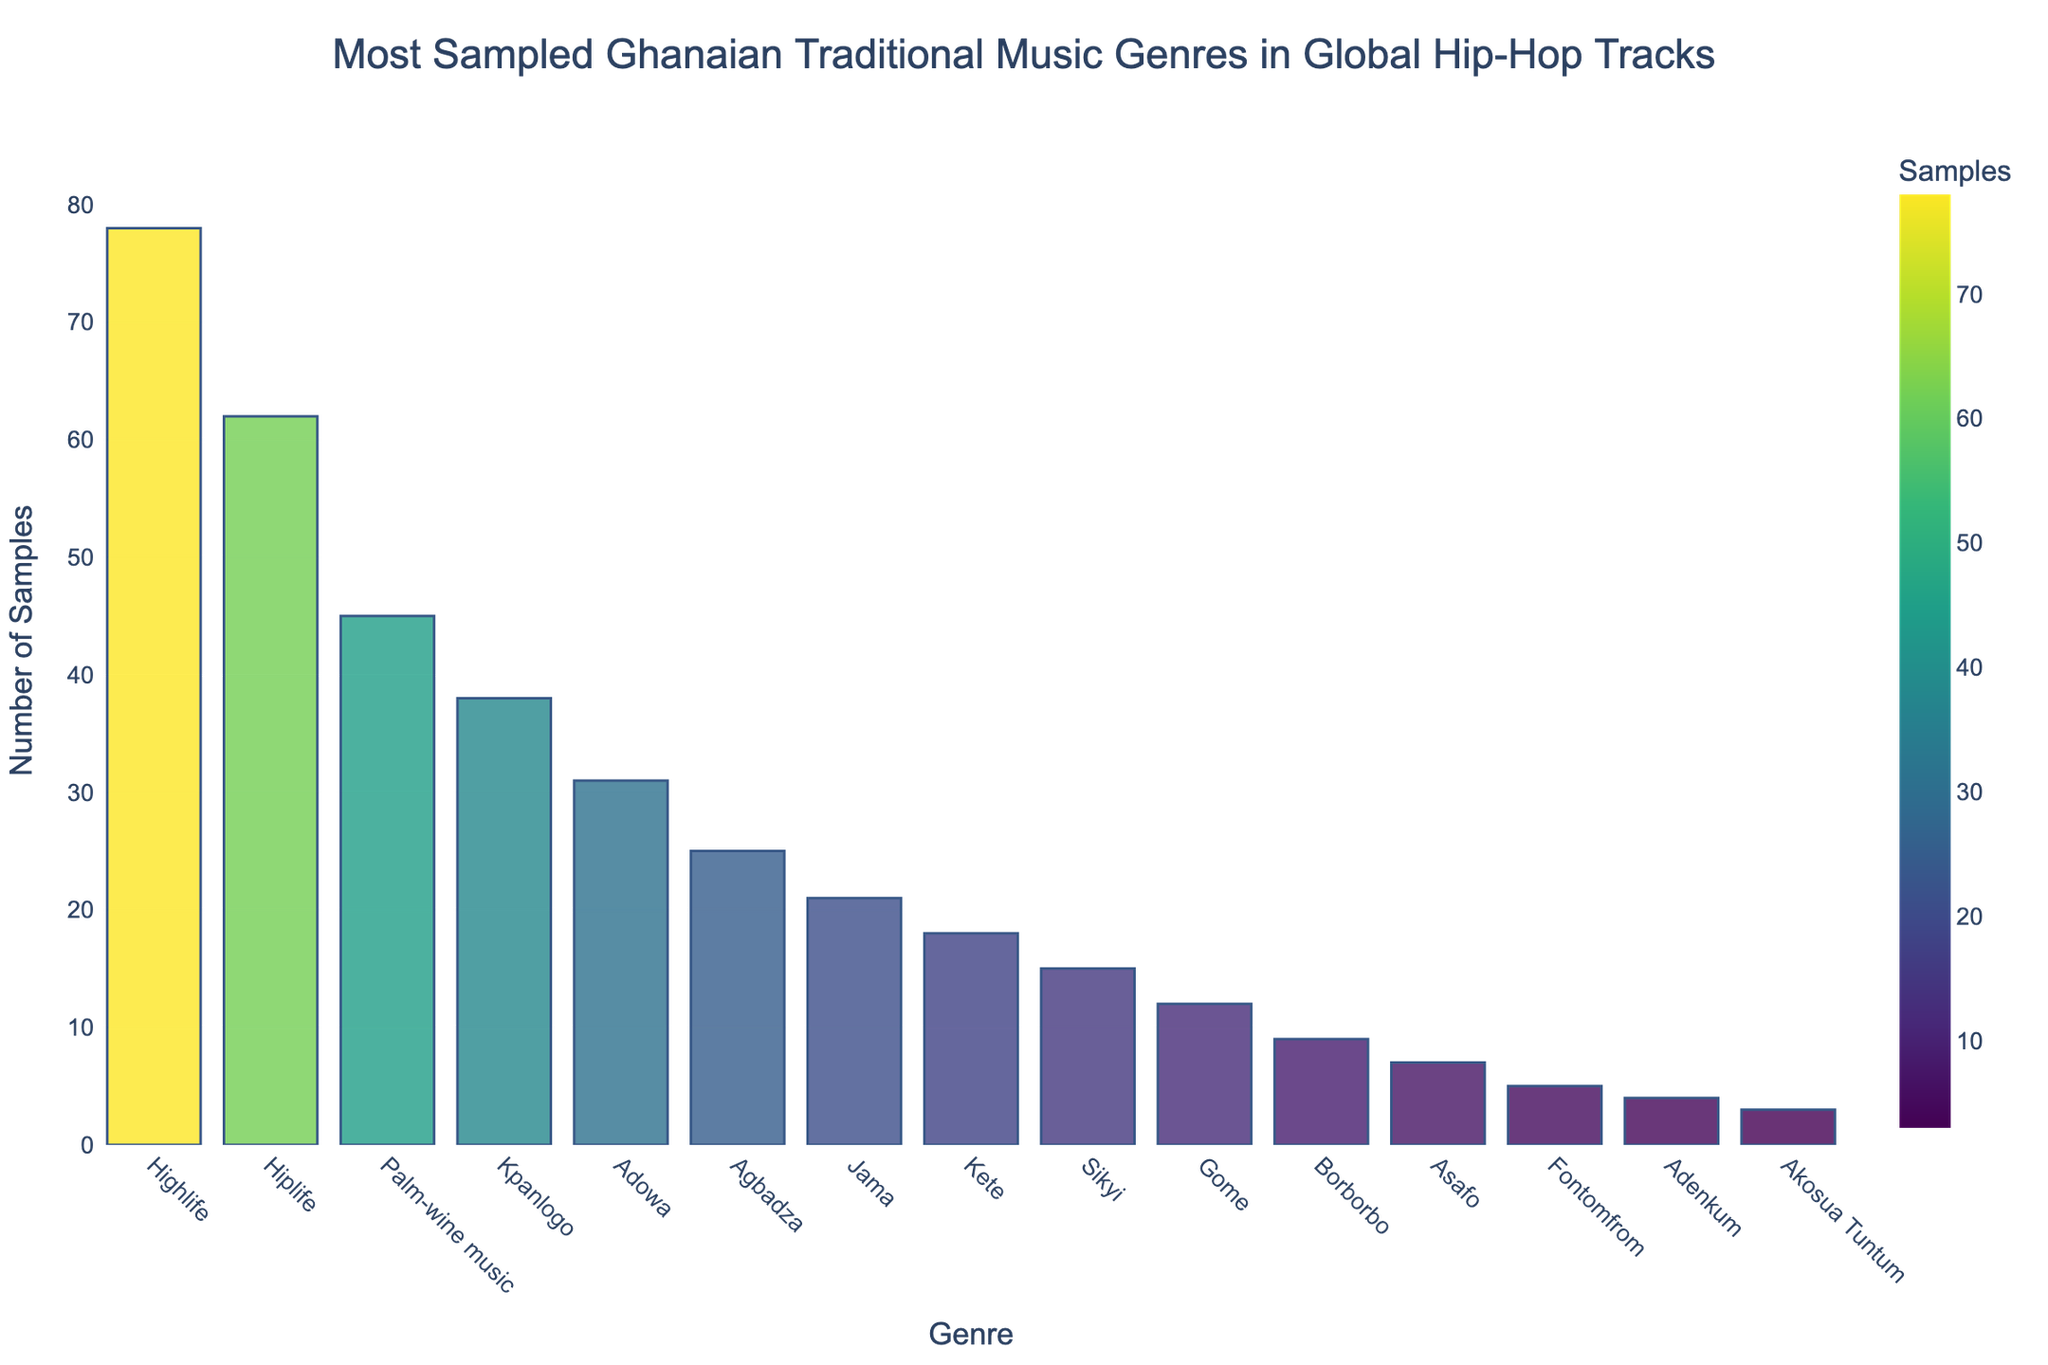What is the most sampled Ghanaian traditional music genre in global hip-hop tracks? The bar chart shows the number of samples for each Ghanaian traditional music genre. By observing the heights of the bars, the 'Highlife' genre stands out as the tallest.
Answer: Highlife What is the least sampled genre shown in the chart? The bar chart shows the number of samples for each genre, and the bar for 'Akosua Tuntum' has the smallest height, indicating it is the least sampled.
Answer: Akosua Tuntum How many more samples does Highlife have compared to Palm-wine music? The chart shows Highlife with 78 samples and Palm-wine music with 45 samples. The difference is calculated as 78 - 45.
Answer: 33 Which genre has more samples, Adowa or Kpanlogo, and by how much? You can compare the bars for Adowa and Kpanlogo. Adowa has 31 samples, and Kpanlogo has 38. The difference is 38 - 31.
Answer: Kpanlogo by 7 What is the total sample count for Highlife, Hiplife, and Kpanlogo? To find the total, add the samples for Highlife (78), Hiplife (62), and Kpanlogo (38). 78 + 62 + 38.
Answer: 178 Which genres have a sample count greater than 40? By examining the heights of the bars, identify the genres with counts higher than 40: Highlife (78), Hiplife (62), and Palm-wine music (45).
Answer: Highlife, Hiplife, Palm-wine music Are there more samples for Kete or Borborbo, and by how much? Kete has 18 samples, while Borborbo has 9. The difference is 18 - 9.
Answer: Kete by 9 What is the combined sample count for genres with less than 10 samples? The genres with less than 10 samples are Borborbo (9), Asafo (7), Fontomfrom (5), Adenkum (4), Akosua Tuntum (3). Add these: 9 + 7 + 5 + 4 + 3.
Answer: 28 What is the average number of samples for the genres shown? First, find the total number of samples for all genres and divide by the number of genres (15). Total samples: 78 + 62 + 45 + 38 + 31 + 25 + 21 + 18 + 15 + 12 + 9 + 7 + 5 + 4 + 3 = 373. Average = 373 / 15.
Answer: 24.87 Identify the genre with the second-highest sample count. The bar chart shows Highlife with the highest samples (78). The next highest bar is Hiplife with 62 samples.
Answer: Hiplife 